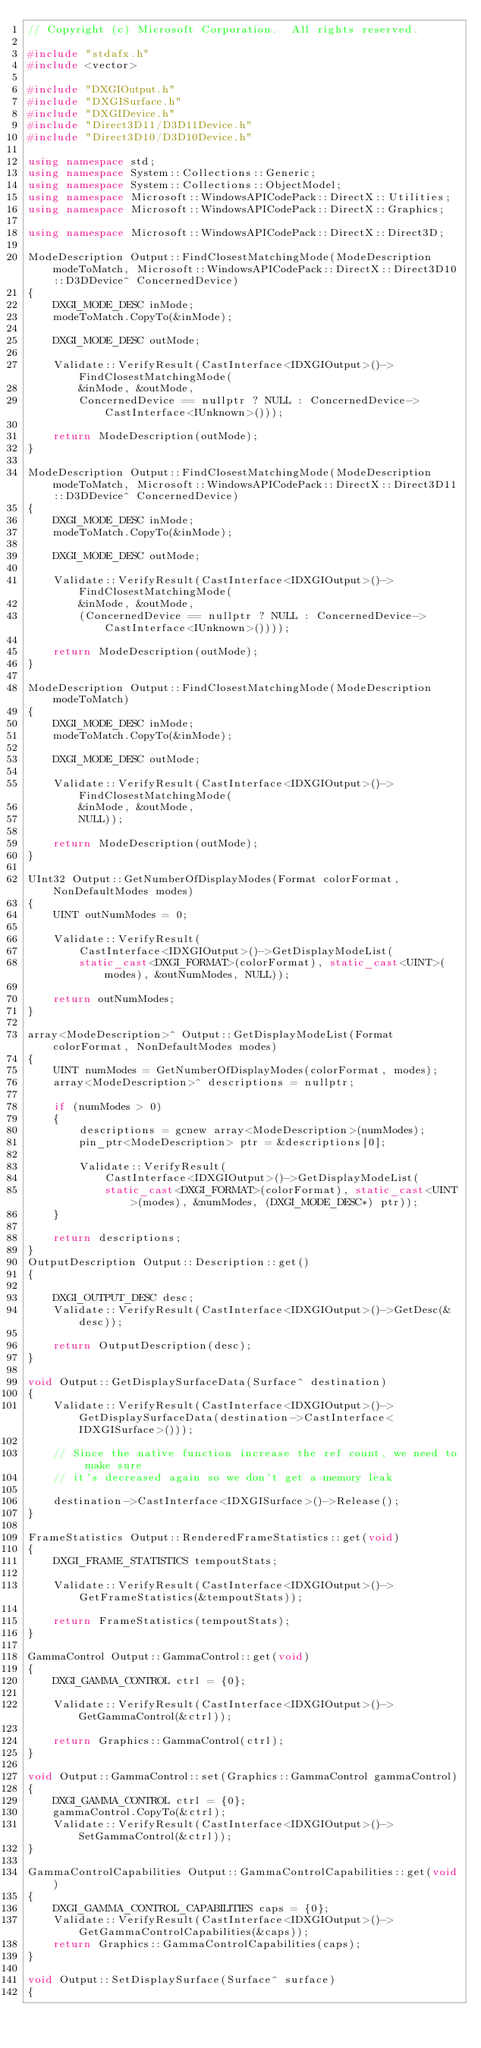<code> <loc_0><loc_0><loc_500><loc_500><_C++_>// Copyright (c) Microsoft Corporation.  All rights reserved.

#include "stdafx.h"
#include <vector>

#include "DXGIOutput.h"
#include "DXGISurface.h"
#include "DXGIDevice.h"
#include "Direct3D11/D3D11Device.h"
#include "Direct3D10/D3D10Device.h"

using namespace std;
using namespace System::Collections::Generic;
using namespace System::Collections::ObjectModel;
using namespace Microsoft::WindowsAPICodePack::DirectX::Utilities;
using namespace Microsoft::WindowsAPICodePack::DirectX::Graphics;

using namespace Microsoft::WindowsAPICodePack::DirectX::Direct3D;

ModeDescription Output::FindClosestMatchingMode(ModeDescription modeToMatch, Microsoft::WindowsAPICodePack::DirectX::Direct3D10::D3DDevice^ ConcernedDevice)
{
    DXGI_MODE_DESC inMode;
    modeToMatch.CopyTo(&inMode);

    DXGI_MODE_DESC outMode;

    Validate::VerifyResult(CastInterface<IDXGIOutput>()->FindClosestMatchingMode(
        &inMode, &outMode, 
        ConcernedDevice == nullptr ? NULL : ConcernedDevice->CastInterface<IUnknown>()));

    return ModeDescription(outMode);
}

ModeDescription Output::FindClosestMatchingMode(ModeDescription modeToMatch, Microsoft::WindowsAPICodePack::DirectX::Direct3D11::D3DDevice^ ConcernedDevice)
{
    DXGI_MODE_DESC inMode;
    modeToMatch.CopyTo(&inMode);

    DXGI_MODE_DESC outMode;

    Validate::VerifyResult(CastInterface<IDXGIOutput>()->FindClosestMatchingMode(
        &inMode, &outMode, 
        (ConcernedDevice == nullptr ? NULL : ConcernedDevice->CastInterface<IUnknown>())));

    return ModeDescription(outMode);
}

ModeDescription Output::FindClosestMatchingMode(ModeDescription modeToMatch)
{
    DXGI_MODE_DESC inMode;
    modeToMatch.CopyTo(&inMode);

    DXGI_MODE_DESC outMode;

    Validate::VerifyResult(CastInterface<IDXGIOutput>()->FindClosestMatchingMode(
        &inMode, &outMode, 
        NULL));
    
    return ModeDescription(outMode);
}

UInt32 Output::GetNumberOfDisplayModes(Format colorFormat, NonDefaultModes modes)
{
    UINT outNumModes = 0;

    Validate::VerifyResult(
        CastInterface<IDXGIOutput>()->GetDisplayModeList(
        static_cast<DXGI_FORMAT>(colorFormat), static_cast<UINT>(modes), &outNumModes, NULL));

    return outNumModes;
}

array<ModeDescription>^ Output::GetDisplayModeList(Format colorFormat, NonDefaultModes modes)
{
    UINT numModes = GetNumberOfDisplayModes(colorFormat, modes);
    array<ModeDescription>^ descriptions = nullptr;

    if (numModes > 0)
    {
        descriptions = gcnew array<ModeDescription>(numModes);
        pin_ptr<ModeDescription> ptr = &descriptions[0];

        Validate::VerifyResult(
            CastInterface<IDXGIOutput>()->GetDisplayModeList(
            static_cast<DXGI_FORMAT>(colorFormat), static_cast<UINT>(modes), &numModes, (DXGI_MODE_DESC*) ptr));
    }

    return descriptions;
}
OutputDescription Output::Description::get()
{

    DXGI_OUTPUT_DESC desc; 
    Validate::VerifyResult(CastInterface<IDXGIOutput>()->GetDesc(&desc));

    return OutputDescription(desc);
}

void Output::GetDisplaySurfaceData(Surface^ destination)
{
    Validate::VerifyResult(CastInterface<IDXGIOutput>()->GetDisplaySurfaceData(destination->CastInterface<IDXGISurface>()));
    
    // Since the native function increase the ref count, we need to make sure 
    // it's decreased again so we don't get a memory leak
    
    destination->CastInterface<IDXGISurface>()->Release();
}

FrameStatistics Output::RenderedFrameStatistics::get(void)
{
    DXGI_FRAME_STATISTICS tempoutStats;
    
    Validate::VerifyResult(CastInterface<IDXGIOutput>()->GetFrameStatistics(&tempoutStats));
    
    return FrameStatistics(tempoutStats);
}

GammaControl Output::GammaControl::get(void)
{
    DXGI_GAMMA_CONTROL ctrl = {0};

    Validate::VerifyResult(CastInterface<IDXGIOutput>()->GetGammaControl(&ctrl));

    return Graphics::GammaControl(ctrl);
}

void Output::GammaControl::set(Graphics::GammaControl gammaControl)
{
    DXGI_GAMMA_CONTROL ctrl = {0};
    gammaControl.CopyTo(&ctrl);
    Validate::VerifyResult(CastInterface<IDXGIOutput>()->SetGammaControl(&ctrl));
}

GammaControlCapabilities Output::GammaControlCapabilities::get(void)
{
    DXGI_GAMMA_CONTROL_CAPABILITIES caps = {0};
    Validate::VerifyResult(CastInterface<IDXGIOutput>()->GetGammaControlCapabilities(&caps));
    return Graphics::GammaControlCapabilities(caps);
}

void Output::SetDisplaySurface(Surface^ surface)
{</code> 